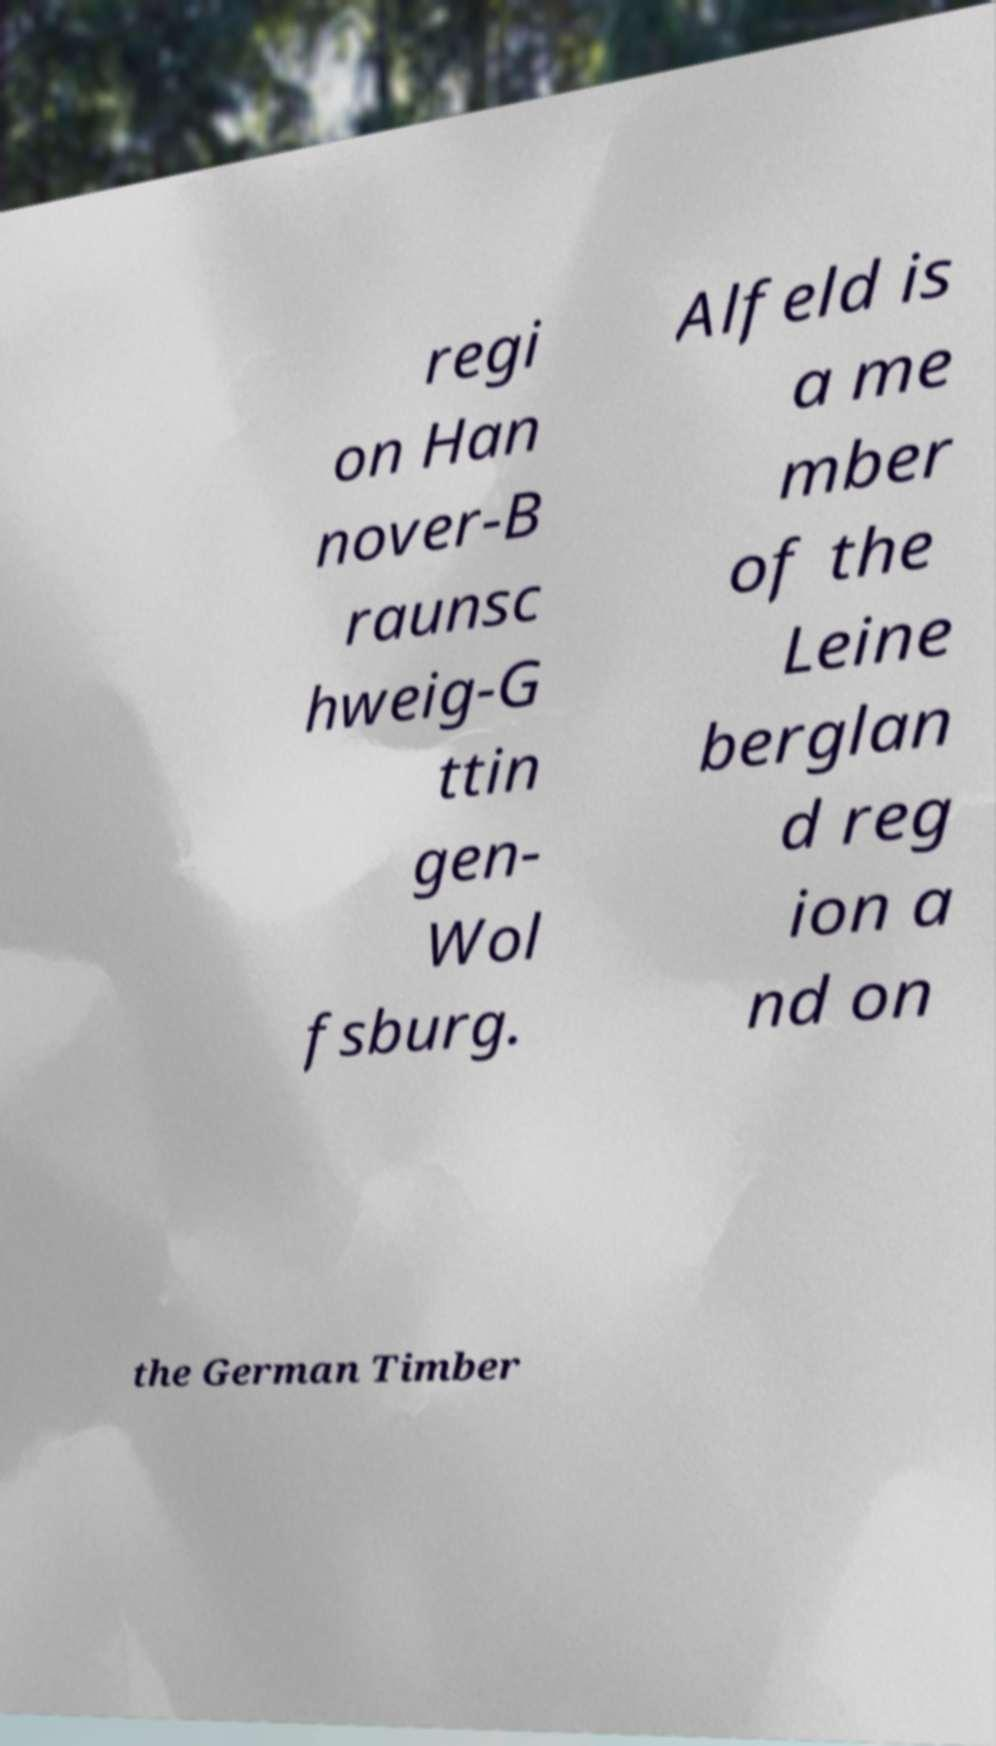Can you accurately transcribe the text from the provided image for me? regi on Han nover-B raunsc hweig-G ttin gen- Wol fsburg. Alfeld is a me mber of the Leine berglan d reg ion a nd on the German Timber 